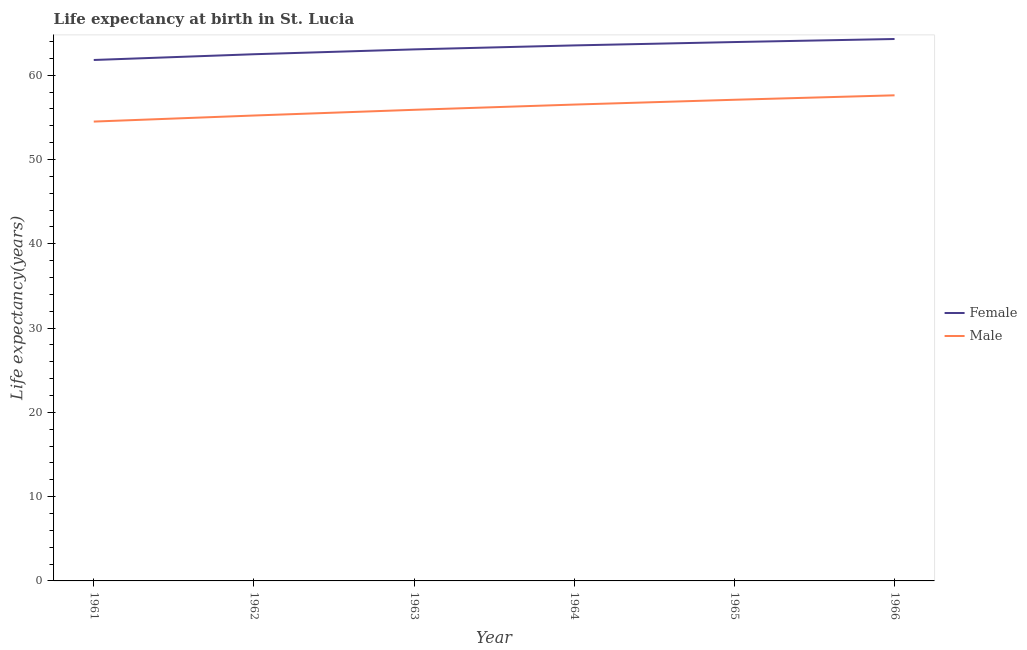How many different coloured lines are there?
Give a very brief answer. 2. What is the life expectancy(male) in 1966?
Your response must be concise. 57.61. Across all years, what is the maximum life expectancy(male)?
Give a very brief answer. 57.61. Across all years, what is the minimum life expectancy(male)?
Provide a succinct answer. 54.5. In which year was the life expectancy(male) maximum?
Provide a succinct answer. 1966. What is the total life expectancy(male) in the graph?
Provide a succinct answer. 336.82. What is the difference between the life expectancy(male) in 1965 and that in 1966?
Your answer should be very brief. -0.53. What is the difference between the life expectancy(female) in 1966 and the life expectancy(male) in 1965?
Your answer should be very brief. 7.21. What is the average life expectancy(male) per year?
Make the answer very short. 56.14. In the year 1962, what is the difference between the life expectancy(male) and life expectancy(female)?
Keep it short and to the point. -7.27. In how many years, is the life expectancy(male) greater than 30 years?
Provide a succinct answer. 6. What is the ratio of the life expectancy(female) in 1965 to that in 1966?
Provide a succinct answer. 0.99. Is the life expectancy(male) in 1962 less than that in 1964?
Offer a very short reply. Yes. What is the difference between the highest and the second highest life expectancy(female)?
Give a very brief answer. 0.36. What is the difference between the highest and the lowest life expectancy(male)?
Make the answer very short. 3.12. Does the life expectancy(female) monotonically increase over the years?
Your answer should be very brief. Yes. Is the life expectancy(male) strictly less than the life expectancy(female) over the years?
Ensure brevity in your answer.  Yes. What is the difference between two consecutive major ticks on the Y-axis?
Your response must be concise. 10. Are the values on the major ticks of Y-axis written in scientific E-notation?
Your answer should be very brief. No. What is the title of the graph?
Keep it short and to the point. Life expectancy at birth in St. Lucia. What is the label or title of the X-axis?
Keep it short and to the point. Year. What is the label or title of the Y-axis?
Your answer should be very brief. Life expectancy(years). What is the Life expectancy(years) in Female in 1961?
Give a very brief answer. 61.8. What is the Life expectancy(years) in Male in 1961?
Make the answer very short. 54.5. What is the Life expectancy(years) in Female in 1962?
Offer a terse response. 62.49. What is the Life expectancy(years) of Male in 1962?
Offer a terse response. 55.22. What is the Life expectancy(years) in Female in 1963?
Provide a short and direct response. 63.06. What is the Life expectancy(years) of Male in 1963?
Ensure brevity in your answer.  55.89. What is the Life expectancy(years) in Female in 1964?
Offer a terse response. 63.53. What is the Life expectancy(years) in Male in 1964?
Give a very brief answer. 56.52. What is the Life expectancy(years) in Female in 1965?
Offer a terse response. 63.93. What is the Life expectancy(years) of Male in 1965?
Provide a short and direct response. 57.09. What is the Life expectancy(years) in Female in 1966?
Your answer should be very brief. 64.29. What is the Life expectancy(years) in Male in 1966?
Keep it short and to the point. 57.61. Across all years, what is the maximum Life expectancy(years) in Female?
Offer a very short reply. 64.29. Across all years, what is the maximum Life expectancy(years) of Male?
Your response must be concise. 57.61. Across all years, what is the minimum Life expectancy(years) of Female?
Give a very brief answer. 61.8. Across all years, what is the minimum Life expectancy(years) in Male?
Your response must be concise. 54.5. What is the total Life expectancy(years) in Female in the graph?
Provide a short and direct response. 379.11. What is the total Life expectancy(years) of Male in the graph?
Provide a short and direct response. 336.82. What is the difference between the Life expectancy(years) in Female in 1961 and that in 1962?
Your answer should be compact. -0.68. What is the difference between the Life expectancy(years) in Male in 1961 and that in 1962?
Ensure brevity in your answer.  -0.72. What is the difference between the Life expectancy(years) of Female in 1961 and that in 1963?
Your response must be concise. -1.26. What is the difference between the Life expectancy(years) in Male in 1961 and that in 1963?
Provide a short and direct response. -1.4. What is the difference between the Life expectancy(years) of Female in 1961 and that in 1964?
Your answer should be very brief. -1.73. What is the difference between the Life expectancy(years) of Male in 1961 and that in 1964?
Your response must be concise. -2.02. What is the difference between the Life expectancy(years) in Female in 1961 and that in 1965?
Provide a short and direct response. -2.13. What is the difference between the Life expectancy(years) in Male in 1961 and that in 1965?
Provide a succinct answer. -2.59. What is the difference between the Life expectancy(years) of Female in 1961 and that in 1966?
Offer a very short reply. -2.49. What is the difference between the Life expectancy(years) of Male in 1961 and that in 1966?
Provide a succinct answer. -3.12. What is the difference between the Life expectancy(years) in Female in 1962 and that in 1963?
Provide a succinct answer. -0.57. What is the difference between the Life expectancy(years) in Male in 1962 and that in 1963?
Your answer should be compact. -0.68. What is the difference between the Life expectancy(years) in Female in 1962 and that in 1964?
Provide a succinct answer. -1.05. What is the difference between the Life expectancy(years) of Male in 1962 and that in 1964?
Your answer should be compact. -1.3. What is the difference between the Life expectancy(years) of Female in 1962 and that in 1965?
Make the answer very short. -1.45. What is the difference between the Life expectancy(years) of Male in 1962 and that in 1965?
Keep it short and to the point. -1.87. What is the difference between the Life expectancy(years) of Female in 1962 and that in 1966?
Your answer should be compact. -1.81. What is the difference between the Life expectancy(years) in Male in 1962 and that in 1966?
Offer a very short reply. -2.4. What is the difference between the Life expectancy(years) in Female in 1963 and that in 1964?
Make the answer very short. -0.47. What is the difference between the Life expectancy(years) of Male in 1963 and that in 1964?
Ensure brevity in your answer.  -0.62. What is the difference between the Life expectancy(years) in Female in 1963 and that in 1965?
Offer a terse response. -0.87. What is the difference between the Life expectancy(years) of Male in 1963 and that in 1965?
Ensure brevity in your answer.  -1.19. What is the difference between the Life expectancy(years) of Female in 1963 and that in 1966?
Keep it short and to the point. -1.23. What is the difference between the Life expectancy(years) in Male in 1963 and that in 1966?
Give a very brief answer. -1.72. What is the difference between the Life expectancy(years) in Female in 1964 and that in 1965?
Make the answer very short. -0.4. What is the difference between the Life expectancy(years) of Male in 1964 and that in 1965?
Your response must be concise. -0.57. What is the difference between the Life expectancy(years) of Female in 1964 and that in 1966?
Your answer should be very brief. -0.76. What is the difference between the Life expectancy(years) in Male in 1964 and that in 1966?
Provide a short and direct response. -1.1. What is the difference between the Life expectancy(years) of Female in 1965 and that in 1966?
Your response must be concise. -0.36. What is the difference between the Life expectancy(years) of Male in 1965 and that in 1966?
Provide a succinct answer. -0.53. What is the difference between the Life expectancy(years) of Female in 1961 and the Life expectancy(years) of Male in 1962?
Provide a succinct answer. 6.59. What is the difference between the Life expectancy(years) in Female in 1961 and the Life expectancy(years) in Male in 1963?
Your answer should be very brief. 5.91. What is the difference between the Life expectancy(years) of Female in 1961 and the Life expectancy(years) of Male in 1964?
Provide a short and direct response. 5.29. What is the difference between the Life expectancy(years) in Female in 1961 and the Life expectancy(years) in Male in 1965?
Offer a terse response. 4.72. What is the difference between the Life expectancy(years) in Female in 1961 and the Life expectancy(years) in Male in 1966?
Your answer should be compact. 4.19. What is the difference between the Life expectancy(years) in Female in 1962 and the Life expectancy(years) in Male in 1963?
Your answer should be very brief. 6.59. What is the difference between the Life expectancy(years) of Female in 1962 and the Life expectancy(years) of Male in 1964?
Give a very brief answer. 5.97. What is the difference between the Life expectancy(years) of Female in 1962 and the Life expectancy(years) of Male in 1965?
Provide a succinct answer. 5.4. What is the difference between the Life expectancy(years) of Female in 1962 and the Life expectancy(years) of Male in 1966?
Ensure brevity in your answer.  4.87. What is the difference between the Life expectancy(years) of Female in 1963 and the Life expectancy(years) of Male in 1964?
Ensure brevity in your answer.  6.55. What is the difference between the Life expectancy(years) of Female in 1963 and the Life expectancy(years) of Male in 1965?
Provide a short and direct response. 5.98. What is the difference between the Life expectancy(years) of Female in 1963 and the Life expectancy(years) of Male in 1966?
Offer a terse response. 5.45. What is the difference between the Life expectancy(years) in Female in 1964 and the Life expectancy(years) in Male in 1965?
Provide a succinct answer. 6.45. What is the difference between the Life expectancy(years) of Female in 1964 and the Life expectancy(years) of Male in 1966?
Offer a very short reply. 5.92. What is the difference between the Life expectancy(years) of Female in 1965 and the Life expectancy(years) of Male in 1966?
Provide a succinct answer. 6.32. What is the average Life expectancy(years) of Female per year?
Your response must be concise. 63.19. What is the average Life expectancy(years) of Male per year?
Offer a very short reply. 56.14. In the year 1961, what is the difference between the Life expectancy(years) of Female and Life expectancy(years) of Male?
Offer a very short reply. 7.31. In the year 1962, what is the difference between the Life expectancy(years) in Female and Life expectancy(years) in Male?
Provide a short and direct response. 7.27. In the year 1963, what is the difference between the Life expectancy(years) of Female and Life expectancy(years) of Male?
Your answer should be very brief. 7.17. In the year 1964, what is the difference between the Life expectancy(years) of Female and Life expectancy(years) of Male?
Provide a succinct answer. 7.02. In the year 1965, what is the difference between the Life expectancy(years) of Female and Life expectancy(years) of Male?
Make the answer very short. 6.85. In the year 1966, what is the difference between the Life expectancy(years) of Female and Life expectancy(years) of Male?
Make the answer very short. 6.68. What is the ratio of the Life expectancy(years) in Female in 1961 to that in 1963?
Ensure brevity in your answer.  0.98. What is the ratio of the Life expectancy(years) of Male in 1961 to that in 1963?
Your response must be concise. 0.97. What is the ratio of the Life expectancy(years) in Female in 1961 to that in 1964?
Your answer should be very brief. 0.97. What is the ratio of the Life expectancy(years) of Female in 1961 to that in 1965?
Your answer should be compact. 0.97. What is the ratio of the Life expectancy(years) in Male in 1961 to that in 1965?
Provide a succinct answer. 0.95. What is the ratio of the Life expectancy(years) of Female in 1961 to that in 1966?
Make the answer very short. 0.96. What is the ratio of the Life expectancy(years) in Male in 1961 to that in 1966?
Your answer should be compact. 0.95. What is the ratio of the Life expectancy(years) in Female in 1962 to that in 1963?
Your response must be concise. 0.99. What is the ratio of the Life expectancy(years) of Male in 1962 to that in 1963?
Offer a very short reply. 0.99. What is the ratio of the Life expectancy(years) of Female in 1962 to that in 1964?
Provide a succinct answer. 0.98. What is the ratio of the Life expectancy(years) in Female in 1962 to that in 1965?
Keep it short and to the point. 0.98. What is the ratio of the Life expectancy(years) in Male in 1962 to that in 1965?
Your response must be concise. 0.97. What is the ratio of the Life expectancy(years) in Female in 1962 to that in 1966?
Your answer should be compact. 0.97. What is the ratio of the Life expectancy(years) in Male in 1962 to that in 1966?
Offer a very short reply. 0.96. What is the ratio of the Life expectancy(years) of Female in 1963 to that in 1964?
Give a very brief answer. 0.99. What is the ratio of the Life expectancy(years) in Female in 1963 to that in 1965?
Make the answer very short. 0.99. What is the ratio of the Life expectancy(years) in Male in 1963 to that in 1965?
Ensure brevity in your answer.  0.98. What is the ratio of the Life expectancy(years) in Female in 1963 to that in 1966?
Provide a succinct answer. 0.98. What is the ratio of the Life expectancy(years) of Male in 1963 to that in 1966?
Provide a succinct answer. 0.97. What is the ratio of the Life expectancy(years) of Female in 1964 to that in 1965?
Offer a terse response. 0.99. What is the ratio of the Life expectancy(years) in Male in 1964 to that in 1965?
Give a very brief answer. 0.99. What is the ratio of the Life expectancy(years) in Female in 1964 to that in 1966?
Keep it short and to the point. 0.99. What is the ratio of the Life expectancy(years) in Male in 1964 to that in 1966?
Your answer should be very brief. 0.98. What is the difference between the highest and the second highest Life expectancy(years) of Female?
Provide a short and direct response. 0.36. What is the difference between the highest and the second highest Life expectancy(years) of Male?
Your response must be concise. 0.53. What is the difference between the highest and the lowest Life expectancy(years) in Female?
Offer a very short reply. 2.49. What is the difference between the highest and the lowest Life expectancy(years) of Male?
Make the answer very short. 3.12. 